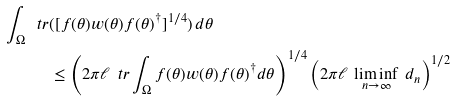Convert formula to latex. <formula><loc_0><loc_0><loc_500><loc_500>\int _ { \Omega } \ t r & ( [ f ( \theta ) w ( \theta ) f ( \theta ) ^ { \dagger } ] ^ { 1 / 4 } ) \, d \theta \\ & \leq \left ( 2 \pi \ell \, \ t r \int _ { \Omega } f ( \theta ) w ( \theta ) f ( \theta ) ^ { \dagger } d \theta \right ) ^ { 1 / 4 } \left ( 2 \pi \ell \, \liminf _ { n \to \infty } \, d _ { n } \right ) ^ { 1 / 2 }</formula> 